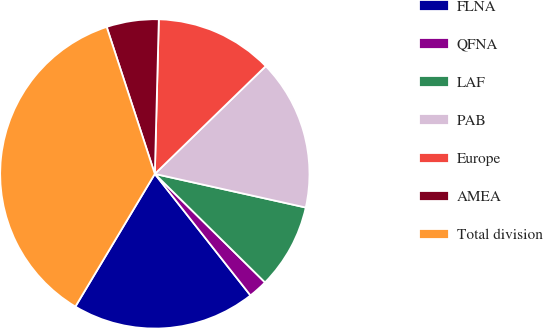<chart> <loc_0><loc_0><loc_500><loc_500><pie_chart><fcel>FLNA<fcel>QFNA<fcel>LAF<fcel>PAB<fcel>Europe<fcel>AMEA<fcel>Total division<nl><fcel>19.2%<fcel>2.01%<fcel>8.89%<fcel>15.76%<fcel>12.32%<fcel>5.45%<fcel>36.38%<nl></chart> 